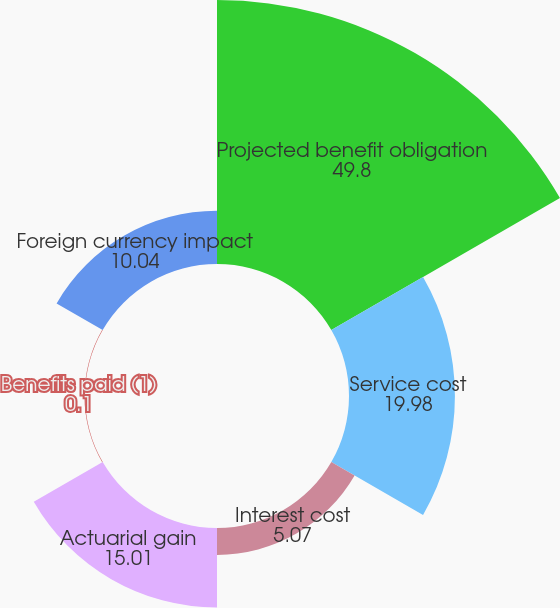<chart> <loc_0><loc_0><loc_500><loc_500><pie_chart><fcel>Projected benefit obligation<fcel>Service cost<fcel>Interest cost<fcel>Actuarial gain<fcel>Benefits paid (1)<fcel>Foreign currency impact<nl><fcel>49.8%<fcel>19.98%<fcel>5.07%<fcel>15.01%<fcel>0.1%<fcel>10.04%<nl></chart> 